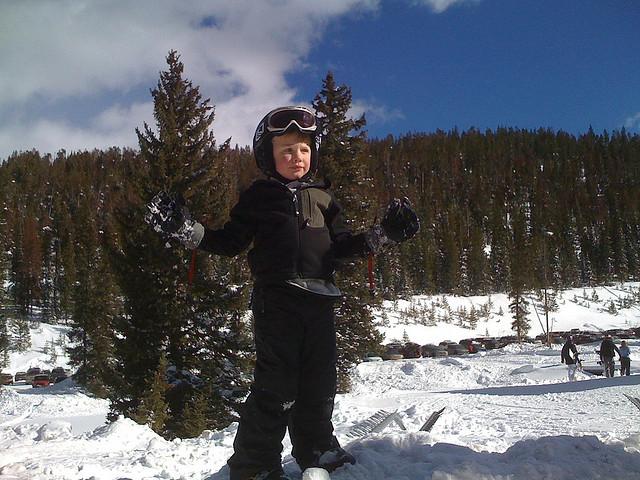Is it cold in the picture?
Quick response, please. Yes. What activity is this child taking part in?
Be succinct. Skiing. How many people are in the photo?
Concise answer only. 4. 